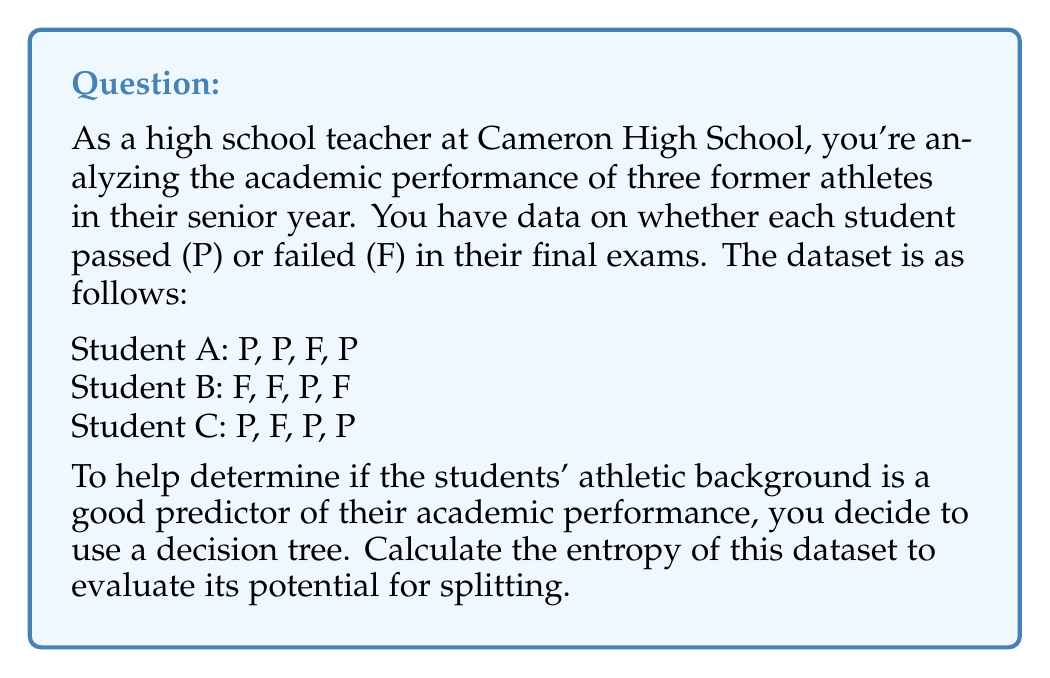Help me with this question. To calculate the entropy of this dataset, we'll follow these steps:

1) First, let's count the total number of instances and the number of each class (P and F):
   Total instances: 12
   P (Pass): 7
   F (Fail): 5

2) Calculate the probability of each class:
   P(Pass) = 7/12
   P(Fail) = 5/12

3) The entropy formula is:
   $$H = -\sum_{i=1}^{n} p_i \log_2(p_i)$$
   where $p_i$ is the probability of class i.

4) Let's substitute our values into the formula:
   $$H = -(\frac{7}{12} \log_2(\frac{7}{12}) + \frac{5}{12} \log_2(\frac{5}{12}))$$

5) Now, let's calculate each part:
   $\frac{7}{12} \log_2(\frac{7}{12}) \approx 0.2716$
   $\frac{5}{12} \log_2(\frac{5}{12}) \approx 0.2157$

6) Summing these up and negating:
   $$H = -(0.2716 + 0.2157) = -0.4873$$

7) Taking the negative:
   $$H = 0.4873$$

8) Therefore, the entropy of the dataset is approximately 0.9873 bits.
Answer: The entropy of the dataset is approximately 0.9873 bits. 